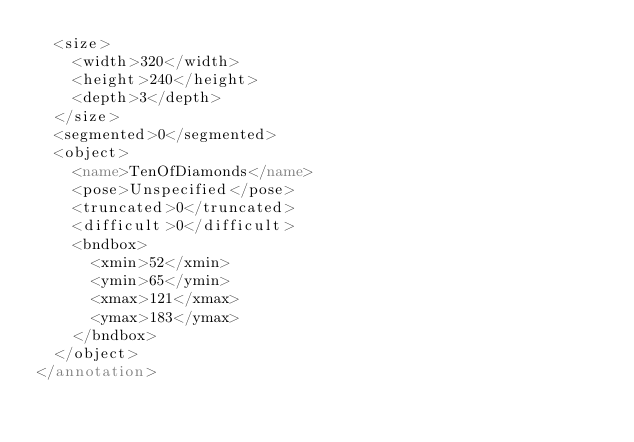<code> <loc_0><loc_0><loc_500><loc_500><_XML_>	<size>
		<width>320</width>
		<height>240</height>
		<depth>3</depth>
	</size>
	<segmented>0</segmented>
	<object>
		<name>TenOfDiamonds</name>
		<pose>Unspecified</pose>
		<truncated>0</truncated>
		<difficult>0</difficult>
		<bndbox>
			<xmin>52</xmin>
			<ymin>65</ymin>
			<xmax>121</xmax>
			<ymax>183</ymax>
		</bndbox>
	</object>
</annotation>
</code> 